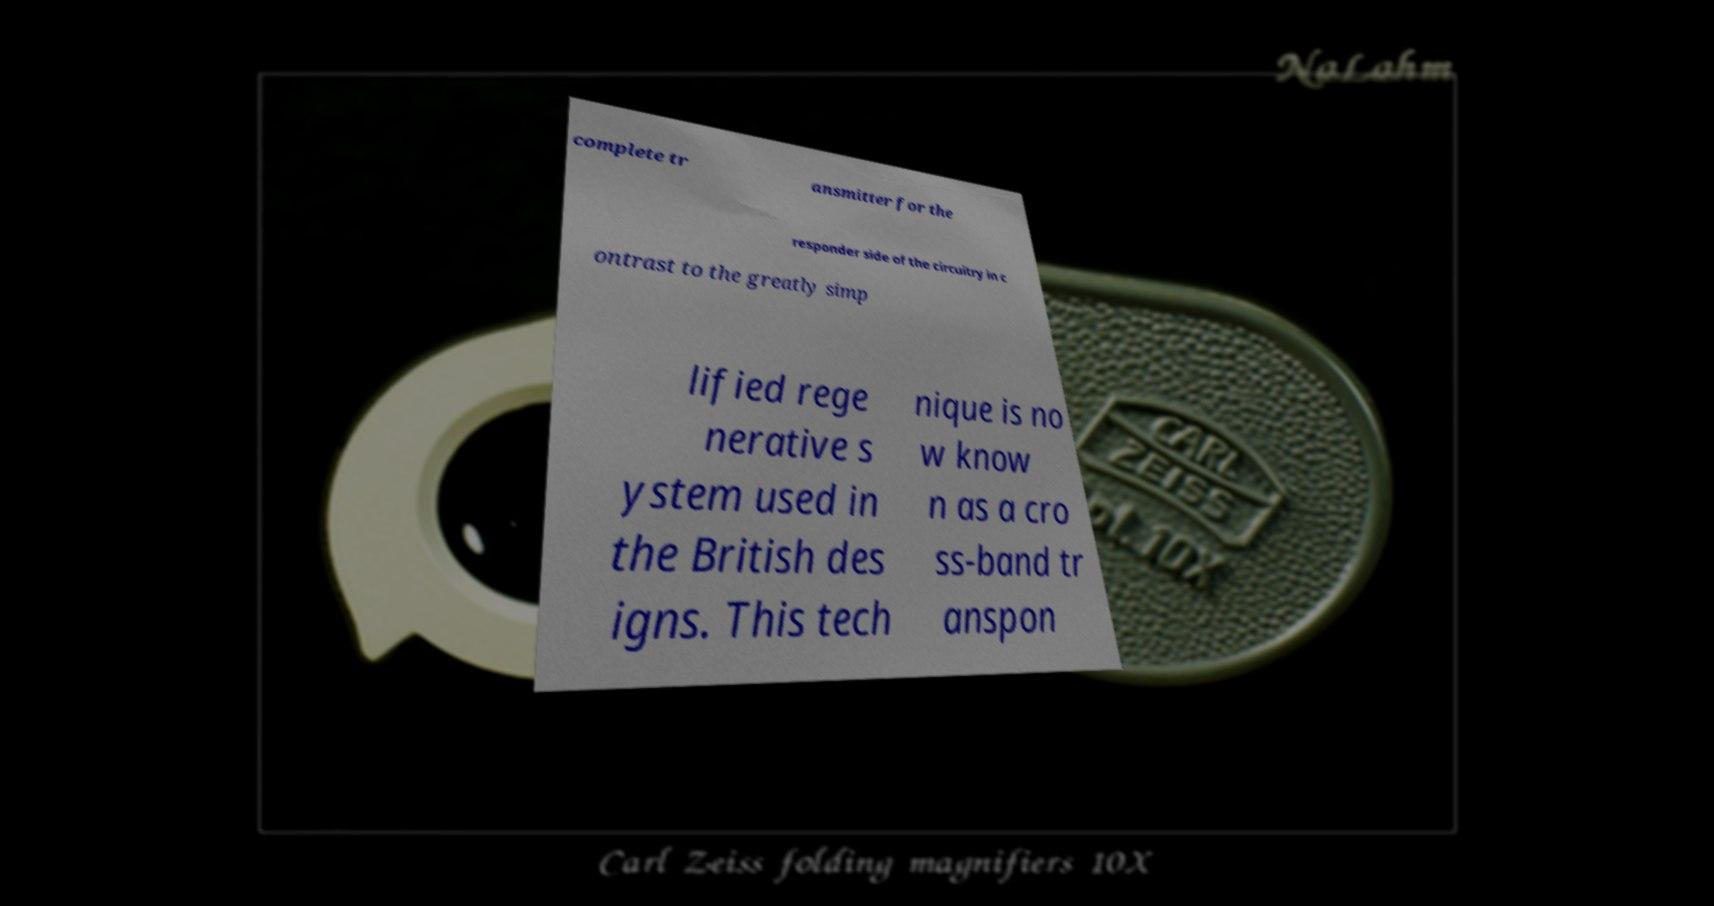There's text embedded in this image that I need extracted. Can you transcribe it verbatim? complete tr ansmitter for the responder side of the circuitry in c ontrast to the greatly simp lified rege nerative s ystem used in the British des igns. This tech nique is no w know n as a cro ss-band tr anspon 